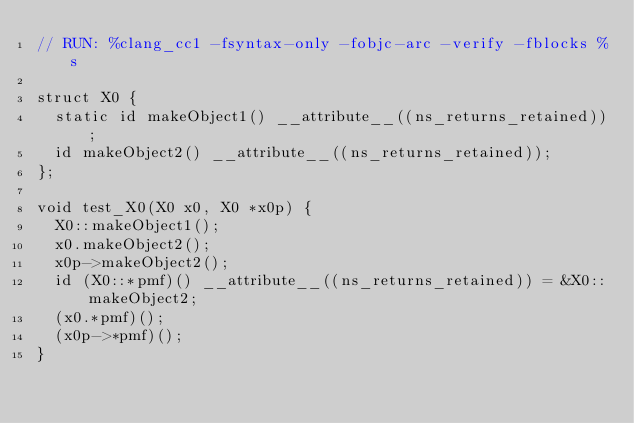<code> <loc_0><loc_0><loc_500><loc_500><_ObjectiveC_>// RUN: %clang_cc1 -fsyntax-only -fobjc-arc -verify -fblocks %s

struct X0 {
  static id makeObject1() __attribute__((ns_returns_retained));
  id makeObject2() __attribute__((ns_returns_retained));
};

void test_X0(X0 x0, X0 *x0p) {
  X0::makeObject1();
  x0.makeObject2();
  x0p->makeObject2();
  id (X0::*pmf)() __attribute__((ns_returns_retained)) = &X0::makeObject2;
  (x0.*pmf)();
  (x0p->*pmf)();
}
</code> 